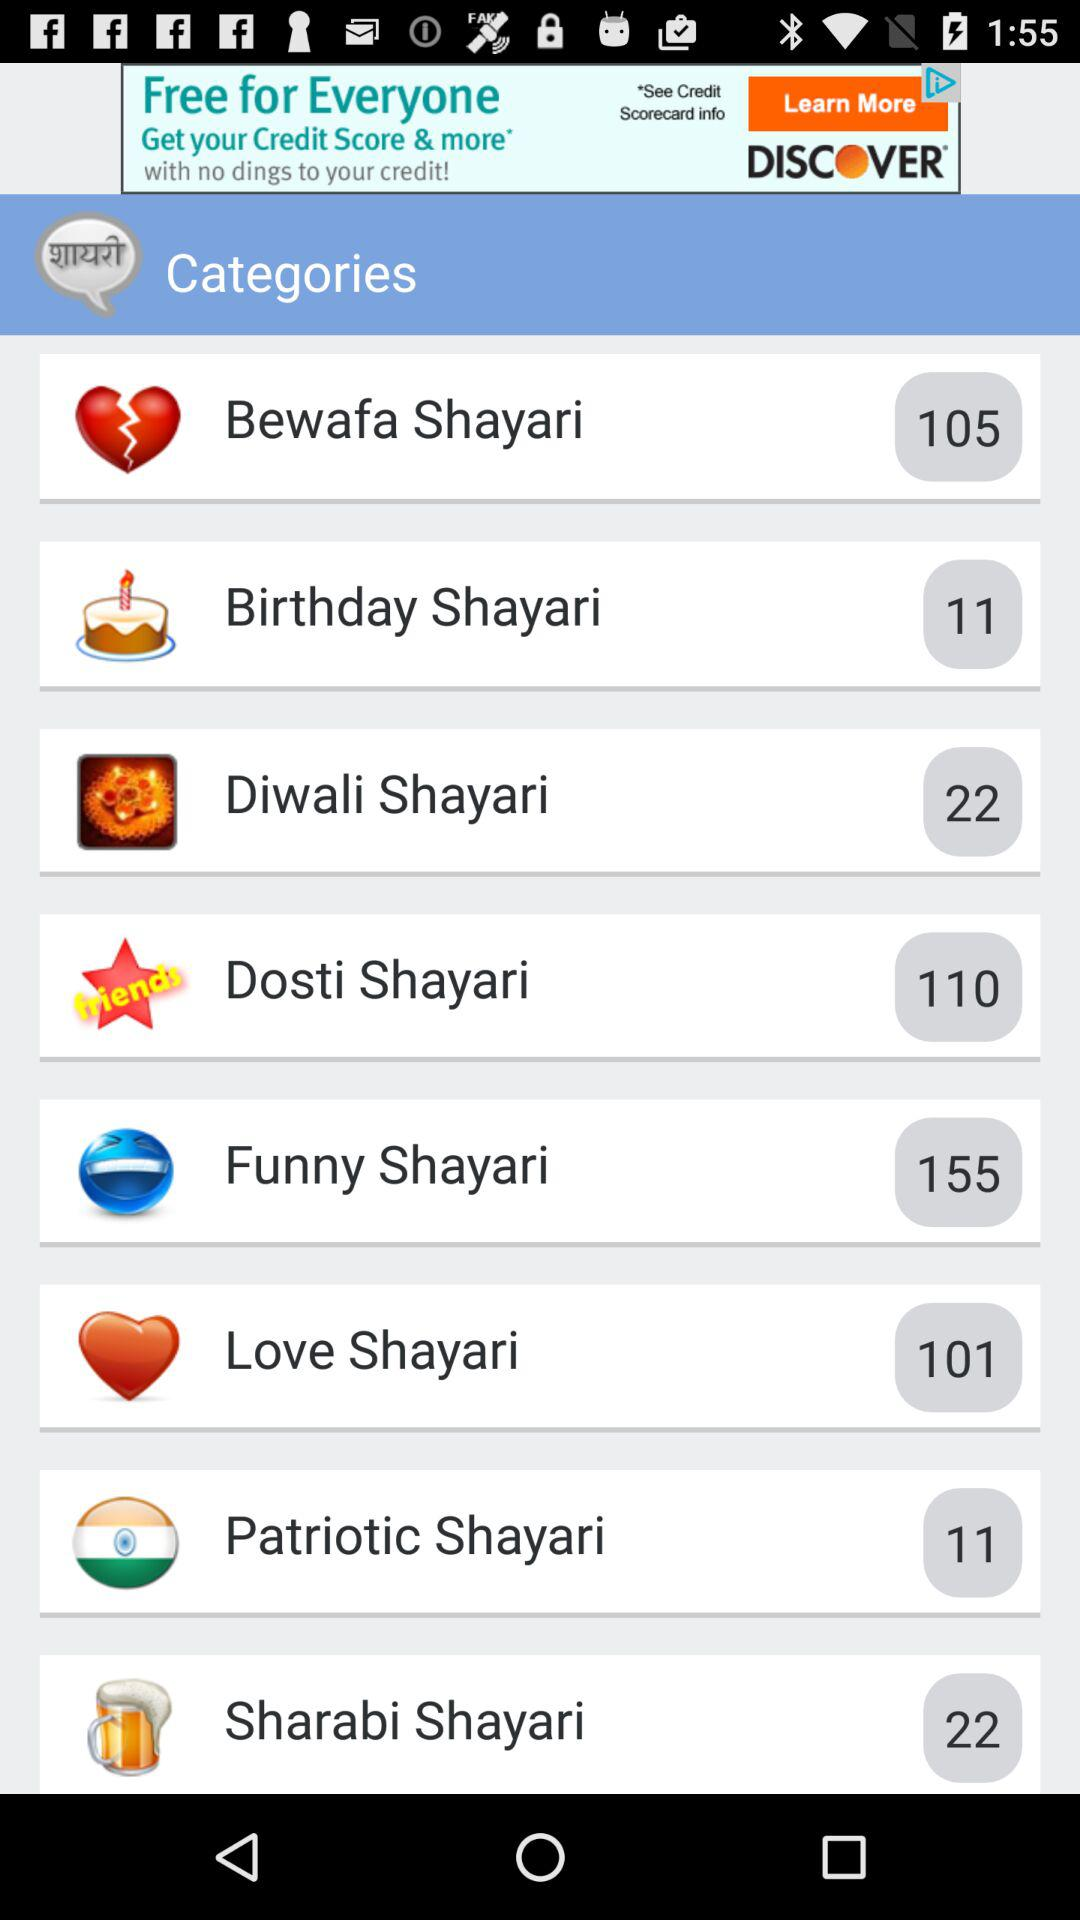Which shayari has 11 numbers? The shayaris that have 11 numbers are "Birthday Shayari" and "Patriotic Shayari". 